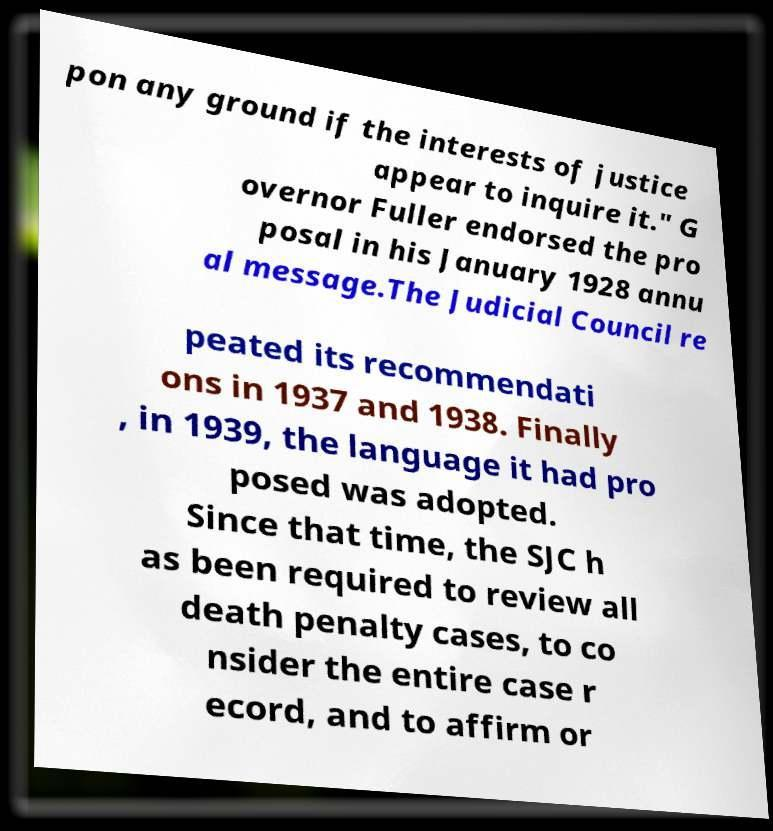Could you assist in decoding the text presented in this image and type it out clearly? pon any ground if the interests of justice appear to inquire it." G overnor Fuller endorsed the pro posal in his January 1928 annu al message.The Judicial Council re peated its recommendati ons in 1937 and 1938. Finally , in 1939, the language it had pro posed was adopted. Since that time, the SJC h as been required to review all death penalty cases, to co nsider the entire case r ecord, and to affirm or 